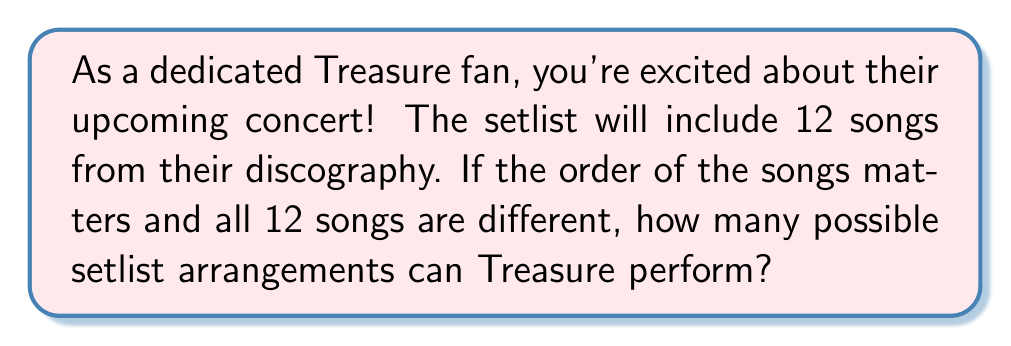Teach me how to tackle this problem. Let's approach this step-by-step:

1) This is a permutation problem. We are arranging all 12 songs, and the order matters.

2) In permutation problems, we use the formula:

   $$P(n) = n!$$

   Where $n$ is the number of items to be arranged.

3) In this case, $n = 12$ (the number of songs in the setlist).

4) So, we need to calculate:

   $$P(12) = 12!$$

5) Let's expand this:

   $$12! = 12 \times 11 \times 10 \times 9 \times 8 \times 7 \times 6 \times 5 \times 4 \times 3 \times 2 \times 1$$

6) Computing this:

   $$12! = 479,001,600$$

Therefore, there are 479,001,600 possible setlist arrangements for Treasure's 12-song concert.
Answer: $479,001,600$ 